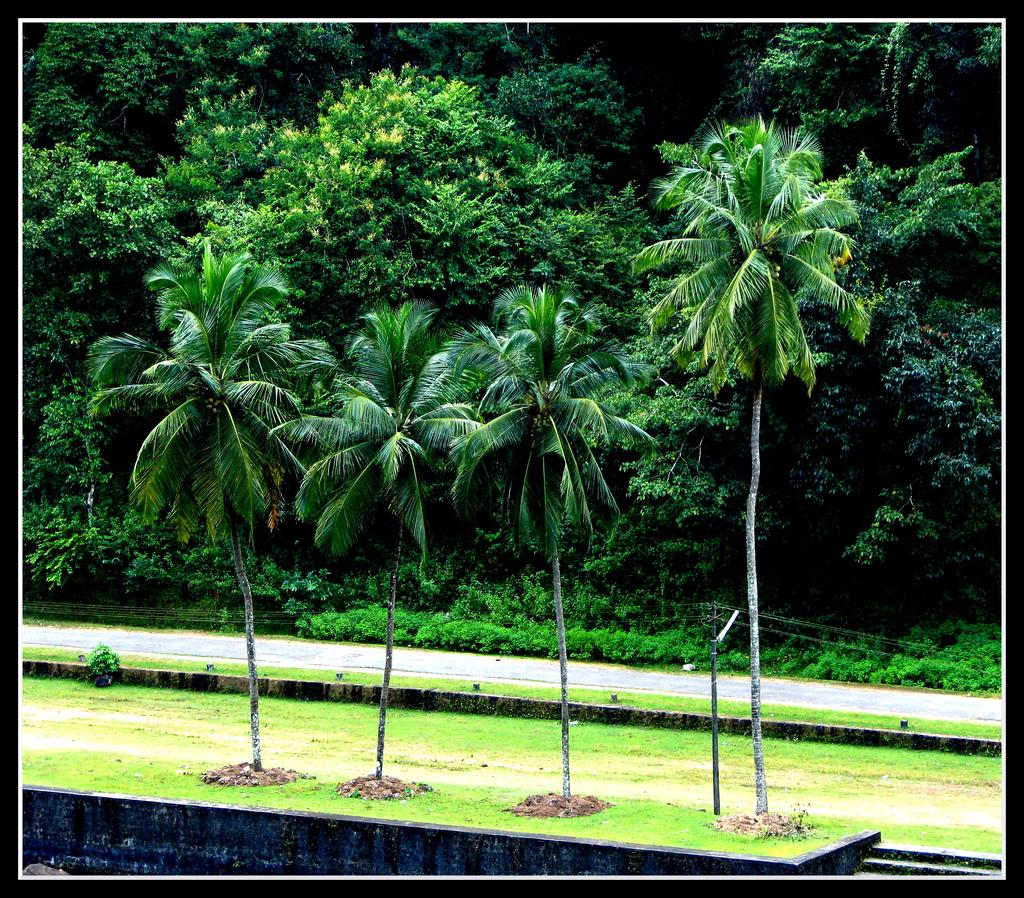What type of vegetation can be seen in the image? There are trees in the image. What is located behind the trees? There is a road behind the trees. What is present behind the road? There is grass behind the road. What can be found further behind the grass? There are additional trees behind the grass. What type of grain is being harvested by the person in the image? There is no person or grain present in the image; it only features trees, a road, grass, and additional trees. 